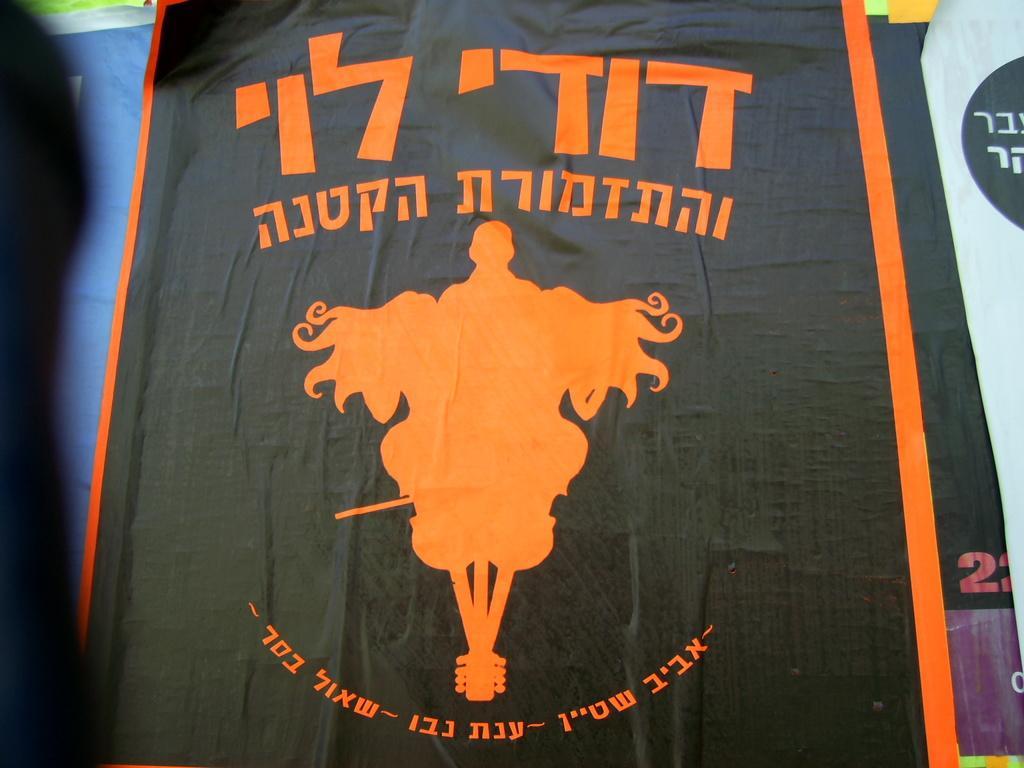Please provide a concise description of this image. In the center of the image there is a black color cloth with orange color design on it and there is some text written. 